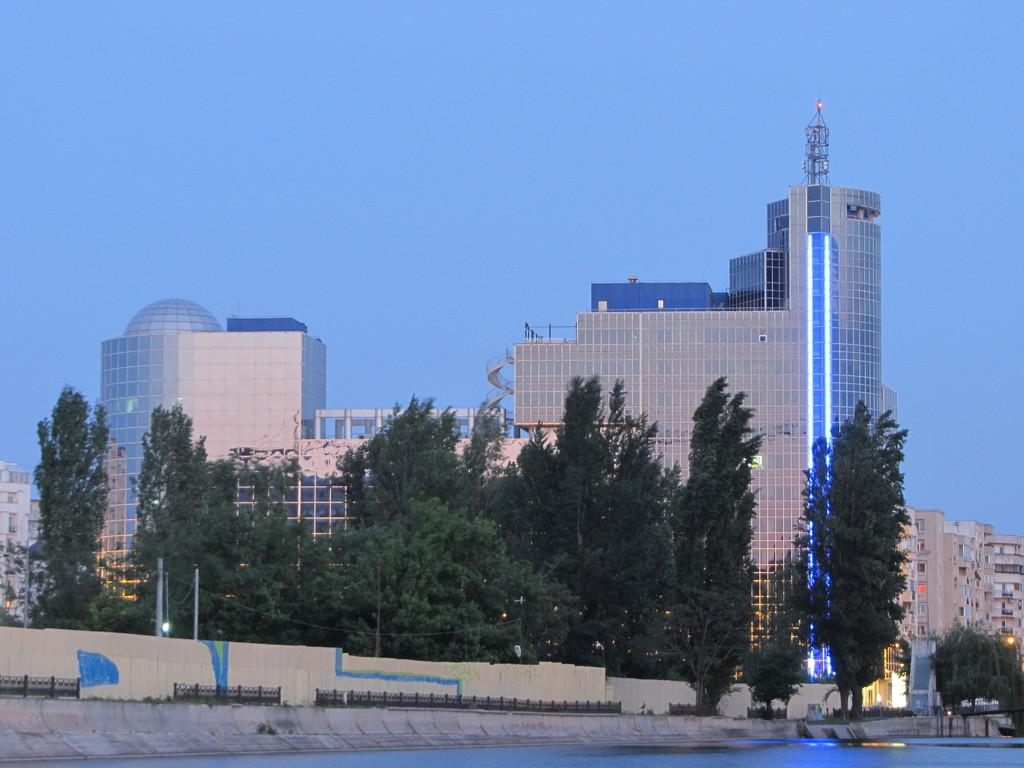What type of structures can be seen in the image? There are buildings in the image. What other natural elements are present in the image? There are trees in the image. What color is the sky in the image? The sky is blue in the image. What body of water can be seen in the image? There is water visible in the image. What type of trail can be seen in the image? There is no trail present in the image. What emotion is being expressed by the canvas in the image? There is no canvas present in the image, so it cannot express any emotion. 